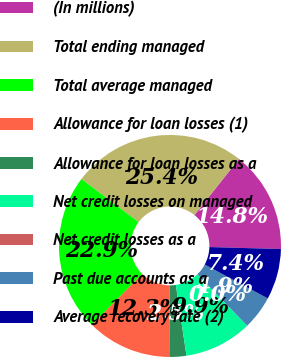Convert chart to OTSL. <chart><loc_0><loc_0><loc_500><loc_500><pie_chart><fcel>(In millions)<fcel>Total ending managed<fcel>Total average managed<fcel>Allowance for loan losses (1)<fcel>Allowance for loan losses as a<fcel>Net credit losses on managed<fcel>Net credit losses as a<fcel>Past due accounts as a<fcel>Average recovery rate (2)<nl><fcel>14.78%<fcel>25.36%<fcel>22.89%<fcel>12.32%<fcel>2.47%<fcel>9.86%<fcel>0.0%<fcel>4.93%<fcel>7.39%<nl></chart> 